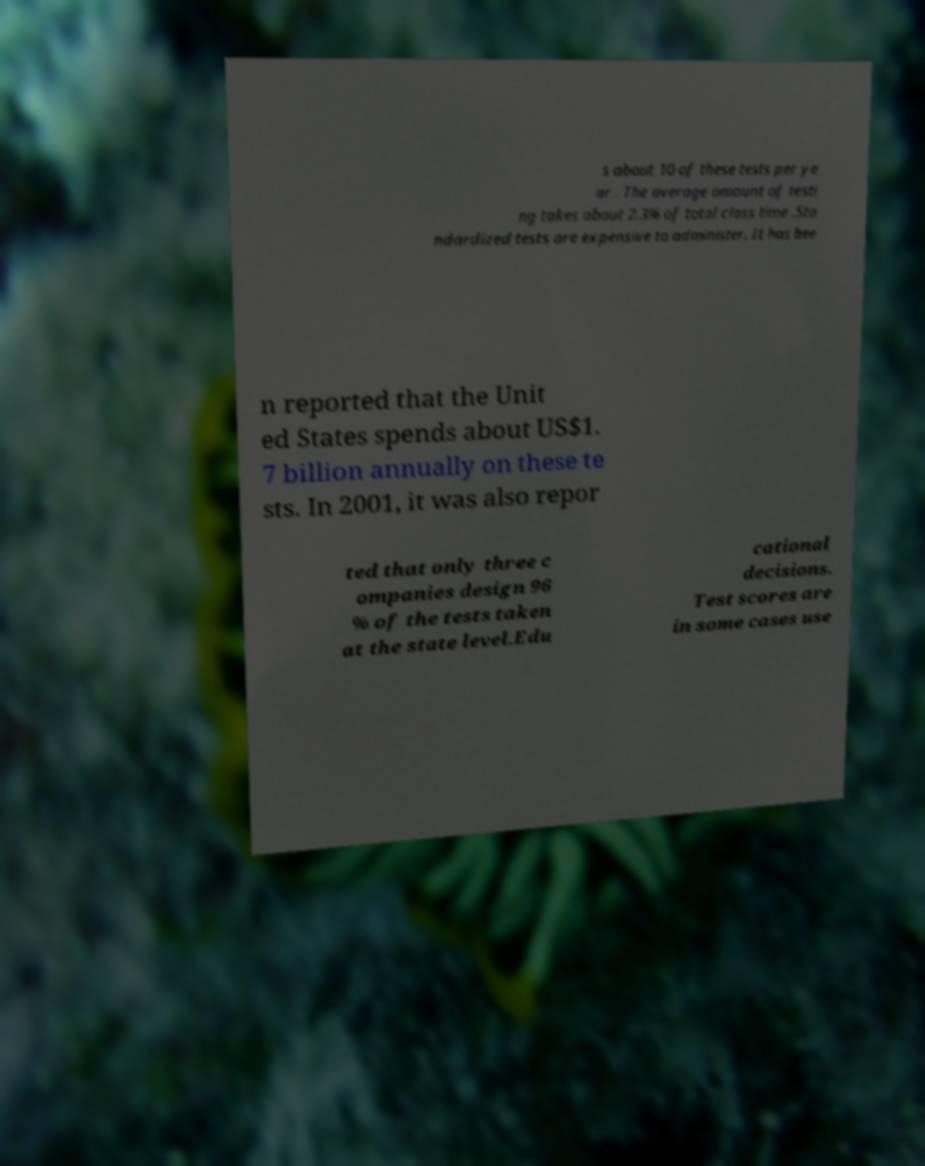What messages or text are displayed in this image? I need them in a readable, typed format. s about 10 of these tests per ye ar . The average amount of testi ng takes about 2.3% of total class time .Sta ndardized tests are expensive to administer. It has bee n reported that the Unit ed States spends about US$1. 7 billion annually on these te sts. In 2001, it was also repor ted that only three c ompanies design 96 % of the tests taken at the state level.Edu cational decisions. Test scores are in some cases use 